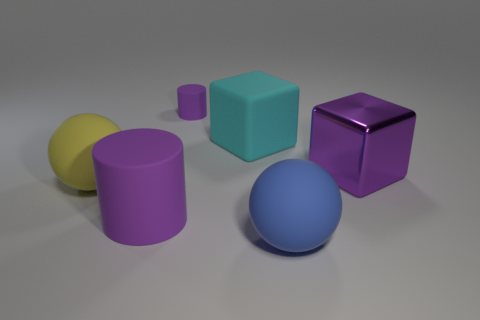Subtract all green spheres. Subtract all yellow cylinders. How many spheres are left? 2 Add 1 small gray rubber cubes. How many objects exist? 7 Subtract all cubes. How many objects are left? 4 Subtract all blue cylinders. Subtract all large shiny cubes. How many objects are left? 5 Add 5 cylinders. How many cylinders are left? 7 Add 1 big blue matte things. How many big blue matte things exist? 2 Subtract 1 purple cylinders. How many objects are left? 5 